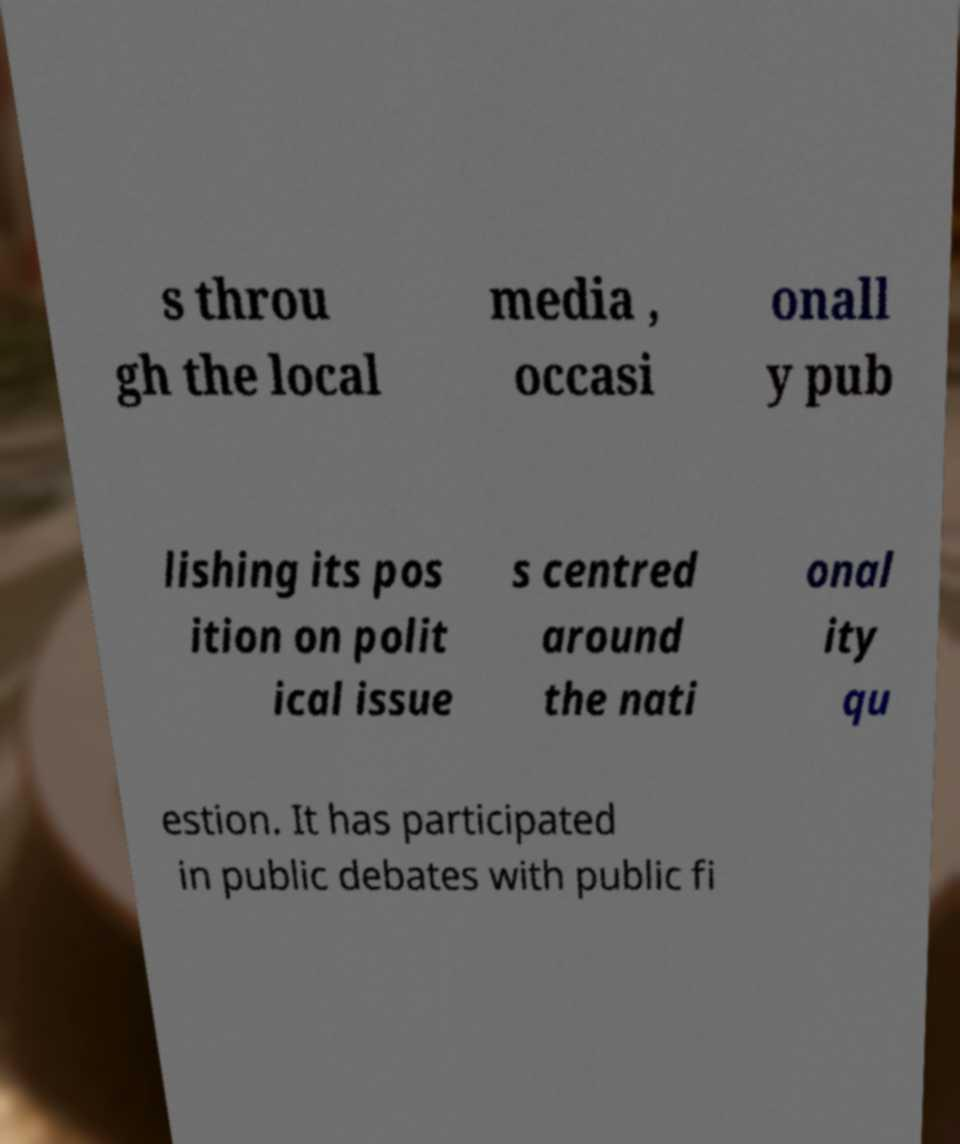For documentation purposes, I need the text within this image transcribed. Could you provide that? s throu gh the local media , occasi onall y pub lishing its pos ition on polit ical issue s centred around the nati onal ity qu estion. It has participated in public debates with public fi 